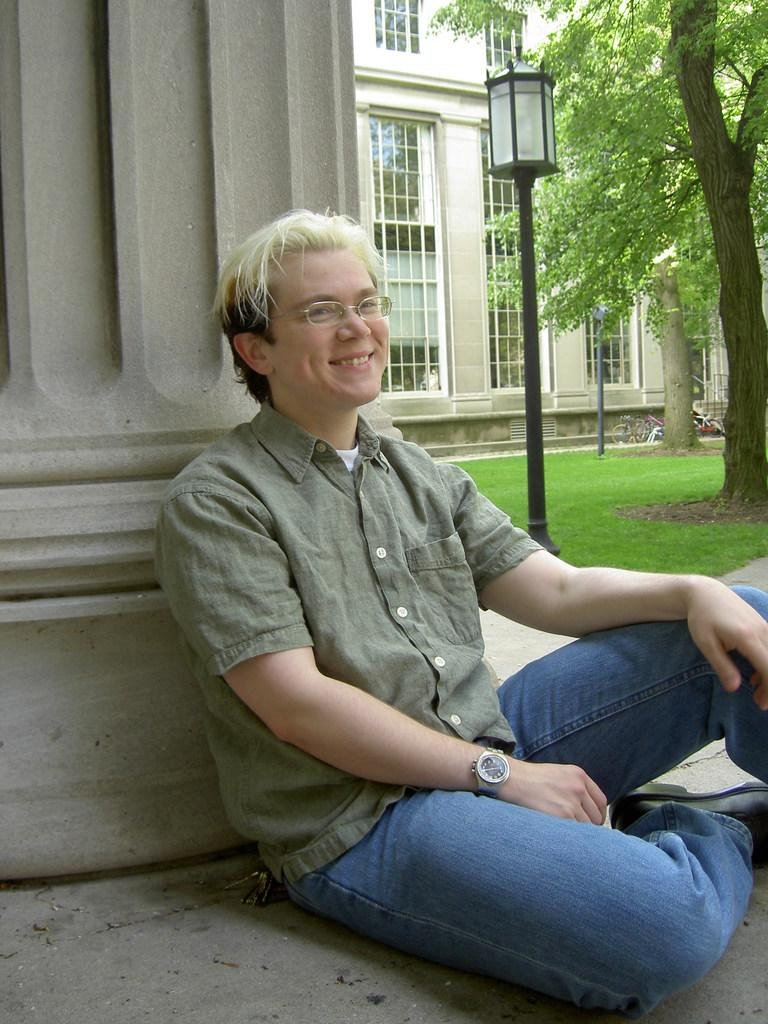What is the man in the image doing? The man is sitting in the image. What is the man wearing? The man is wearing a shirt and jeans trousers. What is the man's facial expression in the image? The man is smiling. What can be seen on the right side of the image? There is a lamp and a tree on the right side of the image. What type of bean is being used as a spoon in the image? There is no bean or spoon present in the image. What shape is the tree on the right side of the image? The provided facts do not mention the shape of the tree, only its presence. 